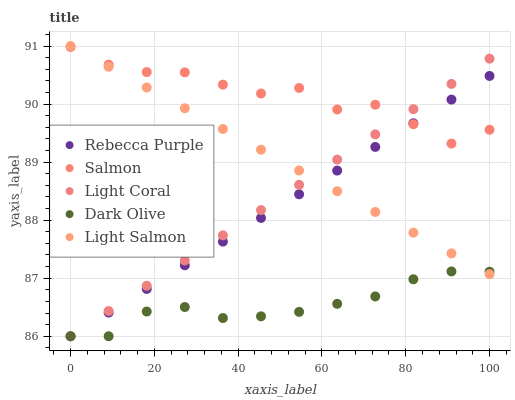Does Dark Olive have the minimum area under the curve?
Answer yes or no. Yes. Does Salmon have the maximum area under the curve?
Answer yes or no. Yes. Does Light Salmon have the minimum area under the curve?
Answer yes or no. No. Does Light Salmon have the maximum area under the curve?
Answer yes or no. No. Is Light Coral the smoothest?
Answer yes or no. Yes. Is Salmon the roughest?
Answer yes or no. Yes. Is Light Salmon the smoothest?
Answer yes or no. No. Is Light Salmon the roughest?
Answer yes or no. No. Does Light Coral have the lowest value?
Answer yes or no. Yes. Does Light Salmon have the lowest value?
Answer yes or no. No. Does Light Salmon have the highest value?
Answer yes or no. Yes. Does Dark Olive have the highest value?
Answer yes or no. No. Is Dark Olive less than Salmon?
Answer yes or no. Yes. Is Salmon greater than Dark Olive?
Answer yes or no. Yes. Does Salmon intersect Light Salmon?
Answer yes or no. Yes. Is Salmon less than Light Salmon?
Answer yes or no. No. Is Salmon greater than Light Salmon?
Answer yes or no. No. Does Dark Olive intersect Salmon?
Answer yes or no. No. 